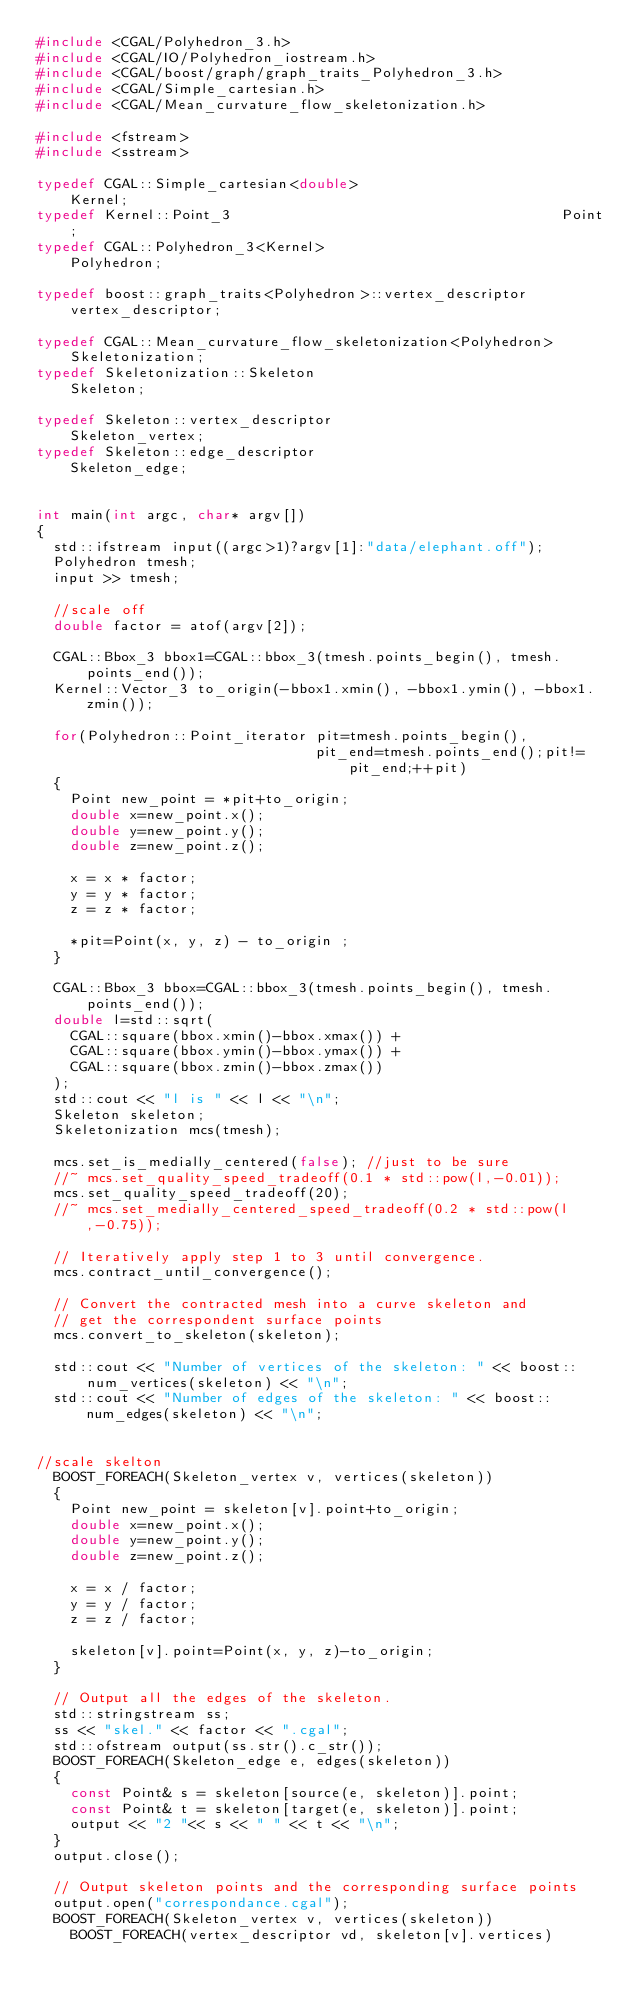Convert code to text. <code><loc_0><loc_0><loc_500><loc_500><_C++_>#include <CGAL/Polyhedron_3.h>
#include <CGAL/IO/Polyhedron_iostream.h>
#include <CGAL/boost/graph/graph_traits_Polyhedron_3.h>
#include <CGAL/Simple_cartesian.h>
#include <CGAL/Mean_curvature_flow_skeletonization.h>

#include <fstream>
#include <sstream>

typedef CGAL::Simple_cartesian<double>                        Kernel;
typedef Kernel::Point_3                                       Point;
typedef CGAL::Polyhedron_3<Kernel>                            Polyhedron;

typedef boost::graph_traits<Polyhedron>::vertex_descriptor    vertex_descriptor;

typedef CGAL::Mean_curvature_flow_skeletonization<Polyhedron> Skeletonization;
typedef Skeletonization::Skeleton                             Skeleton;

typedef Skeleton::vertex_descriptor                           Skeleton_vertex;
typedef Skeleton::edge_descriptor                             Skeleton_edge;


int main(int argc, char* argv[])
{
  std::ifstream input((argc>1)?argv[1]:"data/elephant.off");
  Polyhedron tmesh;
  input >> tmesh;

  //scale off
  double factor = atof(argv[2]);

  CGAL::Bbox_3 bbox1=CGAL::bbox_3(tmesh.points_begin(), tmesh.points_end());
  Kernel::Vector_3 to_origin(-bbox1.xmin(), -bbox1.ymin(), -bbox1.zmin());
  
  for(Polyhedron::Point_iterator pit=tmesh.points_begin(),
                                 pit_end=tmesh.points_end();pit!=pit_end;++pit)
  {
    Point new_point = *pit+to_origin;
    double x=new_point.x();
    double y=new_point.y();
    double z=new_point.z();
    
    x = x * factor;
    y = y * factor;
    z = z * factor;
    
    *pit=Point(x, y, z) - to_origin ;
  }

  CGAL::Bbox_3 bbox=CGAL::bbox_3(tmesh.points_begin(), tmesh.points_end());
  double l=std::sqrt(
    CGAL::square(bbox.xmin()-bbox.xmax()) +
    CGAL::square(bbox.ymin()-bbox.ymax()) +
    CGAL::square(bbox.zmin()-bbox.zmax())
  );
  std::cout << "l is " << l << "\n";
  Skeleton skeleton;
  Skeletonization mcs(tmesh);

  mcs.set_is_medially_centered(false); //just to be sure
  //~ mcs.set_quality_speed_tradeoff(0.1 * std::pow(l,-0.01));
  mcs.set_quality_speed_tradeoff(20);
  //~ mcs.set_medially_centered_speed_tradeoff(0.2 * std::pow(l,-0.75));

  // Iteratively apply step 1 to 3 until convergence.
  mcs.contract_until_convergence();

  // Convert the contracted mesh into a curve skeleton and
  // get the correspondent surface points
  mcs.convert_to_skeleton(skeleton);

  std::cout << "Number of vertices of the skeleton: " << boost::num_vertices(skeleton) << "\n";
  std::cout << "Number of edges of the skeleton: " << boost::num_edges(skeleton) << "\n";


//scale skelton  
  BOOST_FOREACH(Skeleton_vertex v, vertices(skeleton))
  {
    Point new_point = skeleton[v].point+to_origin;
    double x=new_point.x();
    double y=new_point.y();
    double z=new_point.z();
    
    x = x / factor;
    y = y / factor;
    z = z / factor;
    
    skeleton[v].point=Point(x, y, z)-to_origin;
  }

  // Output all the edges of the skeleton.
  std::stringstream ss;
  ss << "skel." << factor << ".cgal"; 
  std::ofstream output(ss.str().c_str());
  BOOST_FOREACH(Skeleton_edge e, edges(skeleton))
  {
    const Point& s = skeleton[source(e, skeleton)].point;
    const Point& t = skeleton[target(e, skeleton)].point;
    output << "2 "<< s << " " << t << "\n";
  }
  output.close();

  // Output skeleton points and the corresponding surface points
  output.open("correspondance.cgal");
  BOOST_FOREACH(Skeleton_vertex v, vertices(skeleton))
    BOOST_FOREACH(vertex_descriptor vd, skeleton[v].vertices)</code> 